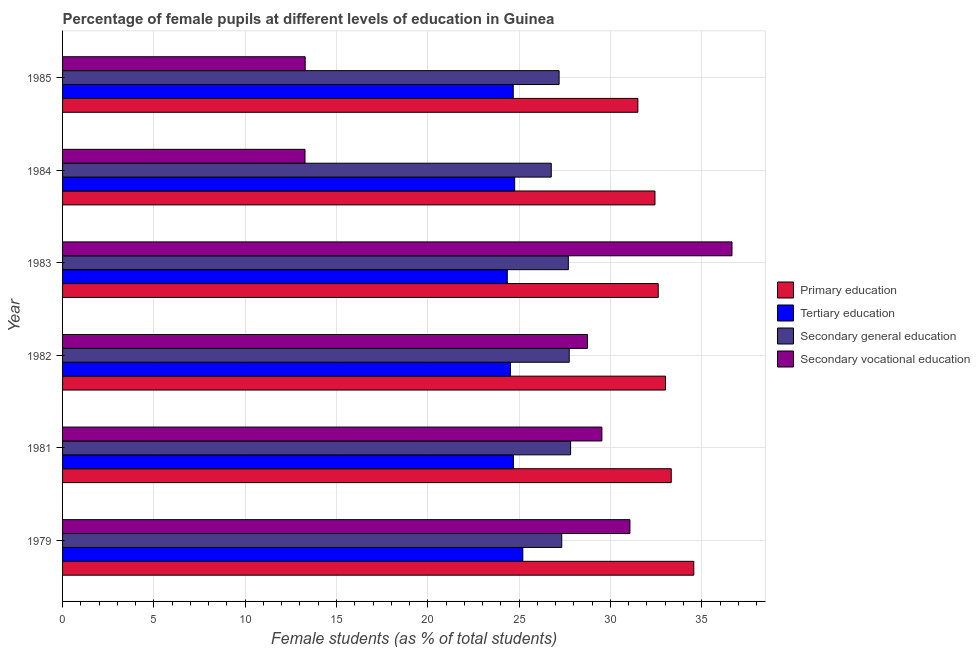How many different coloured bars are there?
Provide a short and direct response. 4. How many groups of bars are there?
Offer a very short reply. 6. How many bars are there on the 3rd tick from the top?
Offer a very short reply. 4. In how many cases, is the number of bars for a given year not equal to the number of legend labels?
Make the answer very short. 0. What is the percentage of female students in tertiary education in 1983?
Keep it short and to the point. 24.35. Across all years, what is the maximum percentage of female students in primary education?
Give a very brief answer. 34.56. Across all years, what is the minimum percentage of female students in secondary vocational education?
Your response must be concise. 13.27. In which year was the percentage of female students in secondary vocational education minimum?
Give a very brief answer. 1984. What is the total percentage of female students in tertiary education in the graph?
Your answer should be very brief. 148.2. What is the difference between the percentage of female students in tertiary education in 1984 and that in 1985?
Provide a short and direct response. 0.08. What is the difference between the percentage of female students in tertiary education in 1982 and the percentage of female students in primary education in 1985?
Offer a very short reply. -6.98. What is the average percentage of female students in tertiary education per year?
Provide a succinct answer. 24.7. In the year 1982, what is the difference between the percentage of female students in primary education and percentage of female students in secondary vocational education?
Give a very brief answer. 4.27. In how many years, is the percentage of female students in secondary vocational education greater than 8 %?
Make the answer very short. 6. What is the ratio of the percentage of female students in primary education in 1984 to that in 1985?
Keep it short and to the point. 1.03. Is the difference between the percentage of female students in secondary education in 1979 and 1984 greater than the difference between the percentage of female students in primary education in 1979 and 1984?
Keep it short and to the point. No. What is the difference between the highest and the second highest percentage of female students in tertiary education?
Your response must be concise. 0.45. What is the difference between the highest and the lowest percentage of female students in secondary education?
Your answer should be compact. 1.06. In how many years, is the percentage of female students in primary education greater than the average percentage of female students in primary education taken over all years?
Offer a very short reply. 3. Is the sum of the percentage of female students in tertiary education in 1983 and 1984 greater than the maximum percentage of female students in secondary vocational education across all years?
Give a very brief answer. Yes. What does the 2nd bar from the top in 1983 represents?
Provide a short and direct response. Secondary general education. What does the 4th bar from the bottom in 1979 represents?
Provide a succinct answer. Secondary vocational education. What is the difference between two consecutive major ticks on the X-axis?
Your answer should be compact. 5. Are the values on the major ticks of X-axis written in scientific E-notation?
Give a very brief answer. No. Does the graph contain any zero values?
Your answer should be compact. No. Does the graph contain grids?
Ensure brevity in your answer.  Yes. Where does the legend appear in the graph?
Provide a short and direct response. Center right. How are the legend labels stacked?
Make the answer very short. Vertical. What is the title of the graph?
Your response must be concise. Percentage of female pupils at different levels of education in Guinea. Does "Luxembourg" appear as one of the legend labels in the graph?
Your answer should be compact. No. What is the label or title of the X-axis?
Keep it short and to the point. Female students (as % of total students). What is the Female students (as % of total students) of Primary education in 1979?
Make the answer very short. 34.56. What is the Female students (as % of total students) of Tertiary education in 1979?
Your response must be concise. 25.2. What is the Female students (as % of total students) of Secondary general education in 1979?
Ensure brevity in your answer.  27.33. What is the Female students (as % of total students) of Secondary vocational education in 1979?
Ensure brevity in your answer.  31.07. What is the Female students (as % of total students) in Primary education in 1981?
Your answer should be very brief. 33.33. What is the Female students (as % of total students) of Tertiary education in 1981?
Offer a terse response. 24.69. What is the Female students (as % of total students) in Secondary general education in 1981?
Give a very brief answer. 27.82. What is the Female students (as % of total students) in Secondary vocational education in 1981?
Offer a very short reply. 29.53. What is the Female students (as % of total students) of Primary education in 1982?
Your answer should be very brief. 33.02. What is the Female students (as % of total students) of Tertiary education in 1982?
Your response must be concise. 24.52. What is the Female students (as % of total students) in Secondary general education in 1982?
Your response must be concise. 27.74. What is the Female students (as % of total students) of Secondary vocational education in 1982?
Give a very brief answer. 28.74. What is the Female students (as % of total students) of Primary education in 1983?
Offer a terse response. 32.62. What is the Female students (as % of total students) in Tertiary education in 1983?
Keep it short and to the point. 24.35. What is the Female students (as % of total students) in Secondary general education in 1983?
Your answer should be very brief. 27.7. What is the Female students (as % of total students) of Secondary vocational education in 1983?
Make the answer very short. 36.66. What is the Female students (as % of total students) of Primary education in 1984?
Your response must be concise. 32.44. What is the Female students (as % of total students) of Tertiary education in 1984?
Make the answer very short. 24.76. What is the Female students (as % of total students) in Secondary general education in 1984?
Your answer should be compact. 26.76. What is the Female students (as % of total students) in Secondary vocational education in 1984?
Make the answer very short. 13.27. What is the Female students (as % of total students) in Primary education in 1985?
Offer a very short reply. 31.5. What is the Female students (as % of total students) in Tertiary education in 1985?
Give a very brief answer. 24.68. What is the Female students (as % of total students) in Secondary general education in 1985?
Provide a short and direct response. 27.19. What is the Female students (as % of total students) of Secondary vocational education in 1985?
Offer a terse response. 13.29. Across all years, what is the maximum Female students (as % of total students) in Primary education?
Keep it short and to the point. 34.56. Across all years, what is the maximum Female students (as % of total students) in Tertiary education?
Your answer should be very brief. 25.2. Across all years, what is the maximum Female students (as % of total students) in Secondary general education?
Your answer should be very brief. 27.82. Across all years, what is the maximum Female students (as % of total students) in Secondary vocational education?
Provide a short and direct response. 36.66. Across all years, what is the minimum Female students (as % of total students) in Primary education?
Keep it short and to the point. 31.5. Across all years, what is the minimum Female students (as % of total students) in Tertiary education?
Provide a succinct answer. 24.35. Across all years, what is the minimum Female students (as % of total students) in Secondary general education?
Offer a terse response. 26.76. Across all years, what is the minimum Female students (as % of total students) in Secondary vocational education?
Offer a terse response. 13.27. What is the total Female students (as % of total students) of Primary education in the graph?
Your response must be concise. 197.47. What is the total Female students (as % of total students) in Tertiary education in the graph?
Give a very brief answer. 148.2. What is the total Female students (as % of total students) of Secondary general education in the graph?
Offer a very short reply. 164.54. What is the total Female students (as % of total students) of Secondary vocational education in the graph?
Offer a very short reply. 152.56. What is the difference between the Female students (as % of total students) of Primary education in 1979 and that in 1981?
Keep it short and to the point. 1.23. What is the difference between the Female students (as % of total students) of Tertiary education in 1979 and that in 1981?
Give a very brief answer. 0.51. What is the difference between the Female students (as % of total students) in Secondary general education in 1979 and that in 1981?
Keep it short and to the point. -0.49. What is the difference between the Female students (as % of total students) of Secondary vocational education in 1979 and that in 1981?
Make the answer very short. 1.54. What is the difference between the Female students (as % of total students) in Primary education in 1979 and that in 1982?
Offer a terse response. 1.55. What is the difference between the Female students (as % of total students) in Tertiary education in 1979 and that in 1982?
Give a very brief answer. 0.68. What is the difference between the Female students (as % of total students) of Secondary general education in 1979 and that in 1982?
Offer a terse response. -0.41. What is the difference between the Female students (as % of total students) in Secondary vocational education in 1979 and that in 1982?
Your answer should be compact. 2.32. What is the difference between the Female students (as % of total students) in Primary education in 1979 and that in 1983?
Give a very brief answer. 1.95. What is the difference between the Female students (as % of total students) in Tertiary education in 1979 and that in 1983?
Provide a succinct answer. 0.85. What is the difference between the Female students (as % of total students) of Secondary general education in 1979 and that in 1983?
Make the answer very short. -0.36. What is the difference between the Female students (as % of total students) in Secondary vocational education in 1979 and that in 1983?
Provide a short and direct response. -5.59. What is the difference between the Female students (as % of total students) of Primary education in 1979 and that in 1984?
Your answer should be compact. 2.13. What is the difference between the Female students (as % of total students) in Tertiary education in 1979 and that in 1984?
Offer a terse response. 0.45. What is the difference between the Female students (as % of total students) of Secondary general education in 1979 and that in 1984?
Provide a short and direct response. 0.57. What is the difference between the Female students (as % of total students) of Secondary vocational education in 1979 and that in 1984?
Your response must be concise. 17.79. What is the difference between the Female students (as % of total students) of Primary education in 1979 and that in 1985?
Your answer should be compact. 3.06. What is the difference between the Female students (as % of total students) of Tertiary education in 1979 and that in 1985?
Your response must be concise. 0.52. What is the difference between the Female students (as % of total students) of Secondary general education in 1979 and that in 1985?
Ensure brevity in your answer.  0.14. What is the difference between the Female students (as % of total students) in Secondary vocational education in 1979 and that in 1985?
Your answer should be very brief. 17.78. What is the difference between the Female students (as % of total students) in Primary education in 1981 and that in 1982?
Give a very brief answer. 0.32. What is the difference between the Female students (as % of total students) of Tertiary education in 1981 and that in 1982?
Your answer should be compact. 0.16. What is the difference between the Female students (as % of total students) in Secondary general education in 1981 and that in 1982?
Your answer should be very brief. 0.07. What is the difference between the Female students (as % of total students) of Secondary vocational education in 1981 and that in 1982?
Your response must be concise. 0.79. What is the difference between the Female students (as % of total students) of Primary education in 1981 and that in 1983?
Provide a short and direct response. 0.71. What is the difference between the Female students (as % of total students) in Tertiary education in 1981 and that in 1983?
Offer a very short reply. 0.34. What is the difference between the Female students (as % of total students) of Secondary general education in 1981 and that in 1983?
Give a very brief answer. 0.12. What is the difference between the Female students (as % of total students) in Secondary vocational education in 1981 and that in 1983?
Your answer should be very brief. -7.12. What is the difference between the Female students (as % of total students) of Primary education in 1981 and that in 1984?
Make the answer very short. 0.89. What is the difference between the Female students (as % of total students) in Tertiary education in 1981 and that in 1984?
Make the answer very short. -0.07. What is the difference between the Female students (as % of total students) of Secondary general education in 1981 and that in 1984?
Your answer should be very brief. 1.06. What is the difference between the Female students (as % of total students) of Secondary vocational education in 1981 and that in 1984?
Provide a short and direct response. 16.26. What is the difference between the Female students (as % of total students) of Primary education in 1981 and that in 1985?
Your answer should be compact. 1.83. What is the difference between the Female students (as % of total students) in Tertiary education in 1981 and that in 1985?
Provide a short and direct response. 0.01. What is the difference between the Female students (as % of total students) of Secondary general education in 1981 and that in 1985?
Keep it short and to the point. 0.63. What is the difference between the Female students (as % of total students) in Secondary vocational education in 1981 and that in 1985?
Offer a very short reply. 16.25. What is the difference between the Female students (as % of total students) in Primary education in 1982 and that in 1983?
Your answer should be very brief. 0.4. What is the difference between the Female students (as % of total students) in Tertiary education in 1982 and that in 1983?
Offer a terse response. 0.17. What is the difference between the Female students (as % of total students) in Secondary general education in 1982 and that in 1983?
Provide a short and direct response. 0.05. What is the difference between the Female students (as % of total students) in Secondary vocational education in 1982 and that in 1983?
Ensure brevity in your answer.  -7.91. What is the difference between the Female students (as % of total students) of Primary education in 1982 and that in 1984?
Provide a short and direct response. 0.58. What is the difference between the Female students (as % of total students) in Tertiary education in 1982 and that in 1984?
Offer a terse response. -0.23. What is the difference between the Female students (as % of total students) of Secondary general education in 1982 and that in 1984?
Your answer should be compact. 0.98. What is the difference between the Female students (as % of total students) of Secondary vocational education in 1982 and that in 1984?
Offer a terse response. 15.47. What is the difference between the Female students (as % of total students) of Primary education in 1982 and that in 1985?
Your answer should be very brief. 1.51. What is the difference between the Female students (as % of total students) of Tertiary education in 1982 and that in 1985?
Keep it short and to the point. -0.15. What is the difference between the Female students (as % of total students) of Secondary general education in 1982 and that in 1985?
Keep it short and to the point. 0.55. What is the difference between the Female students (as % of total students) in Secondary vocational education in 1982 and that in 1985?
Offer a terse response. 15.46. What is the difference between the Female students (as % of total students) of Primary education in 1983 and that in 1984?
Offer a terse response. 0.18. What is the difference between the Female students (as % of total students) of Tertiary education in 1983 and that in 1984?
Give a very brief answer. -0.4. What is the difference between the Female students (as % of total students) in Secondary general education in 1983 and that in 1984?
Provide a succinct answer. 0.94. What is the difference between the Female students (as % of total students) of Secondary vocational education in 1983 and that in 1984?
Provide a short and direct response. 23.38. What is the difference between the Female students (as % of total students) in Primary education in 1983 and that in 1985?
Your answer should be compact. 1.11. What is the difference between the Female students (as % of total students) of Tertiary education in 1983 and that in 1985?
Ensure brevity in your answer.  -0.33. What is the difference between the Female students (as % of total students) of Secondary general education in 1983 and that in 1985?
Provide a succinct answer. 0.51. What is the difference between the Female students (as % of total students) in Secondary vocational education in 1983 and that in 1985?
Keep it short and to the point. 23.37. What is the difference between the Female students (as % of total students) in Primary education in 1984 and that in 1985?
Ensure brevity in your answer.  0.94. What is the difference between the Female students (as % of total students) in Tertiary education in 1984 and that in 1985?
Make the answer very short. 0.08. What is the difference between the Female students (as % of total students) in Secondary general education in 1984 and that in 1985?
Offer a very short reply. -0.43. What is the difference between the Female students (as % of total students) of Secondary vocational education in 1984 and that in 1985?
Your answer should be very brief. -0.01. What is the difference between the Female students (as % of total students) in Primary education in 1979 and the Female students (as % of total students) in Tertiary education in 1981?
Offer a terse response. 9.88. What is the difference between the Female students (as % of total students) in Primary education in 1979 and the Female students (as % of total students) in Secondary general education in 1981?
Provide a short and direct response. 6.75. What is the difference between the Female students (as % of total students) in Primary education in 1979 and the Female students (as % of total students) in Secondary vocational education in 1981?
Your response must be concise. 5.03. What is the difference between the Female students (as % of total students) of Tertiary education in 1979 and the Female students (as % of total students) of Secondary general education in 1981?
Ensure brevity in your answer.  -2.62. What is the difference between the Female students (as % of total students) of Tertiary education in 1979 and the Female students (as % of total students) of Secondary vocational education in 1981?
Make the answer very short. -4.33. What is the difference between the Female students (as % of total students) in Secondary general education in 1979 and the Female students (as % of total students) in Secondary vocational education in 1981?
Your answer should be compact. -2.2. What is the difference between the Female students (as % of total students) of Primary education in 1979 and the Female students (as % of total students) of Tertiary education in 1982?
Ensure brevity in your answer.  10.04. What is the difference between the Female students (as % of total students) of Primary education in 1979 and the Female students (as % of total students) of Secondary general education in 1982?
Ensure brevity in your answer.  6.82. What is the difference between the Female students (as % of total students) of Primary education in 1979 and the Female students (as % of total students) of Secondary vocational education in 1982?
Make the answer very short. 5.82. What is the difference between the Female students (as % of total students) of Tertiary education in 1979 and the Female students (as % of total students) of Secondary general education in 1982?
Keep it short and to the point. -2.54. What is the difference between the Female students (as % of total students) in Tertiary education in 1979 and the Female students (as % of total students) in Secondary vocational education in 1982?
Make the answer very short. -3.54. What is the difference between the Female students (as % of total students) in Secondary general education in 1979 and the Female students (as % of total students) in Secondary vocational education in 1982?
Provide a short and direct response. -1.41. What is the difference between the Female students (as % of total students) in Primary education in 1979 and the Female students (as % of total students) in Tertiary education in 1983?
Your answer should be very brief. 10.21. What is the difference between the Female students (as % of total students) in Primary education in 1979 and the Female students (as % of total students) in Secondary general education in 1983?
Ensure brevity in your answer.  6.87. What is the difference between the Female students (as % of total students) of Primary education in 1979 and the Female students (as % of total students) of Secondary vocational education in 1983?
Your answer should be very brief. -2.09. What is the difference between the Female students (as % of total students) of Tertiary education in 1979 and the Female students (as % of total students) of Secondary general education in 1983?
Your answer should be very brief. -2.49. What is the difference between the Female students (as % of total students) in Tertiary education in 1979 and the Female students (as % of total students) in Secondary vocational education in 1983?
Offer a terse response. -11.45. What is the difference between the Female students (as % of total students) of Secondary general education in 1979 and the Female students (as % of total students) of Secondary vocational education in 1983?
Offer a very short reply. -9.32. What is the difference between the Female students (as % of total students) of Primary education in 1979 and the Female students (as % of total students) of Tertiary education in 1984?
Your response must be concise. 9.81. What is the difference between the Female students (as % of total students) of Primary education in 1979 and the Female students (as % of total students) of Secondary general education in 1984?
Offer a very short reply. 7.8. What is the difference between the Female students (as % of total students) in Primary education in 1979 and the Female students (as % of total students) in Secondary vocational education in 1984?
Your answer should be compact. 21.29. What is the difference between the Female students (as % of total students) of Tertiary education in 1979 and the Female students (as % of total students) of Secondary general education in 1984?
Provide a succinct answer. -1.56. What is the difference between the Female students (as % of total students) of Tertiary education in 1979 and the Female students (as % of total students) of Secondary vocational education in 1984?
Offer a very short reply. 11.93. What is the difference between the Female students (as % of total students) in Secondary general education in 1979 and the Female students (as % of total students) in Secondary vocational education in 1984?
Offer a terse response. 14.06. What is the difference between the Female students (as % of total students) in Primary education in 1979 and the Female students (as % of total students) in Tertiary education in 1985?
Offer a very short reply. 9.89. What is the difference between the Female students (as % of total students) in Primary education in 1979 and the Female students (as % of total students) in Secondary general education in 1985?
Provide a succinct answer. 7.38. What is the difference between the Female students (as % of total students) in Primary education in 1979 and the Female students (as % of total students) in Secondary vocational education in 1985?
Your response must be concise. 21.28. What is the difference between the Female students (as % of total students) in Tertiary education in 1979 and the Female students (as % of total students) in Secondary general education in 1985?
Provide a succinct answer. -1.99. What is the difference between the Female students (as % of total students) of Tertiary education in 1979 and the Female students (as % of total students) of Secondary vocational education in 1985?
Give a very brief answer. 11.92. What is the difference between the Female students (as % of total students) in Secondary general education in 1979 and the Female students (as % of total students) in Secondary vocational education in 1985?
Your answer should be compact. 14.05. What is the difference between the Female students (as % of total students) in Primary education in 1981 and the Female students (as % of total students) in Tertiary education in 1982?
Your answer should be compact. 8.81. What is the difference between the Female students (as % of total students) in Primary education in 1981 and the Female students (as % of total students) in Secondary general education in 1982?
Offer a very short reply. 5.59. What is the difference between the Female students (as % of total students) of Primary education in 1981 and the Female students (as % of total students) of Secondary vocational education in 1982?
Make the answer very short. 4.59. What is the difference between the Female students (as % of total students) in Tertiary education in 1981 and the Female students (as % of total students) in Secondary general education in 1982?
Your answer should be compact. -3.06. What is the difference between the Female students (as % of total students) in Tertiary education in 1981 and the Female students (as % of total students) in Secondary vocational education in 1982?
Keep it short and to the point. -4.06. What is the difference between the Female students (as % of total students) in Secondary general education in 1981 and the Female students (as % of total students) in Secondary vocational education in 1982?
Provide a succinct answer. -0.93. What is the difference between the Female students (as % of total students) in Primary education in 1981 and the Female students (as % of total students) in Tertiary education in 1983?
Your answer should be compact. 8.98. What is the difference between the Female students (as % of total students) of Primary education in 1981 and the Female students (as % of total students) of Secondary general education in 1983?
Ensure brevity in your answer.  5.64. What is the difference between the Female students (as % of total students) in Primary education in 1981 and the Female students (as % of total students) in Secondary vocational education in 1983?
Make the answer very short. -3.33. What is the difference between the Female students (as % of total students) in Tertiary education in 1981 and the Female students (as % of total students) in Secondary general education in 1983?
Offer a terse response. -3.01. What is the difference between the Female students (as % of total students) of Tertiary education in 1981 and the Female students (as % of total students) of Secondary vocational education in 1983?
Your answer should be very brief. -11.97. What is the difference between the Female students (as % of total students) in Secondary general education in 1981 and the Female students (as % of total students) in Secondary vocational education in 1983?
Give a very brief answer. -8.84. What is the difference between the Female students (as % of total students) of Primary education in 1981 and the Female students (as % of total students) of Tertiary education in 1984?
Provide a short and direct response. 8.57. What is the difference between the Female students (as % of total students) of Primary education in 1981 and the Female students (as % of total students) of Secondary general education in 1984?
Offer a terse response. 6.57. What is the difference between the Female students (as % of total students) of Primary education in 1981 and the Female students (as % of total students) of Secondary vocational education in 1984?
Give a very brief answer. 20.06. What is the difference between the Female students (as % of total students) of Tertiary education in 1981 and the Female students (as % of total students) of Secondary general education in 1984?
Your response must be concise. -2.07. What is the difference between the Female students (as % of total students) in Tertiary education in 1981 and the Female students (as % of total students) in Secondary vocational education in 1984?
Your response must be concise. 11.41. What is the difference between the Female students (as % of total students) of Secondary general education in 1981 and the Female students (as % of total students) of Secondary vocational education in 1984?
Ensure brevity in your answer.  14.54. What is the difference between the Female students (as % of total students) in Primary education in 1981 and the Female students (as % of total students) in Tertiary education in 1985?
Offer a terse response. 8.65. What is the difference between the Female students (as % of total students) in Primary education in 1981 and the Female students (as % of total students) in Secondary general education in 1985?
Give a very brief answer. 6.14. What is the difference between the Female students (as % of total students) of Primary education in 1981 and the Female students (as % of total students) of Secondary vocational education in 1985?
Your answer should be very brief. 20.04. What is the difference between the Female students (as % of total students) of Tertiary education in 1981 and the Female students (as % of total students) of Secondary general education in 1985?
Keep it short and to the point. -2.5. What is the difference between the Female students (as % of total students) of Tertiary education in 1981 and the Female students (as % of total students) of Secondary vocational education in 1985?
Offer a very short reply. 11.4. What is the difference between the Female students (as % of total students) in Secondary general education in 1981 and the Female students (as % of total students) in Secondary vocational education in 1985?
Your response must be concise. 14.53. What is the difference between the Female students (as % of total students) in Primary education in 1982 and the Female students (as % of total students) in Tertiary education in 1983?
Your answer should be very brief. 8.66. What is the difference between the Female students (as % of total students) of Primary education in 1982 and the Female students (as % of total students) of Secondary general education in 1983?
Your answer should be compact. 5.32. What is the difference between the Female students (as % of total students) in Primary education in 1982 and the Female students (as % of total students) in Secondary vocational education in 1983?
Offer a very short reply. -3.64. What is the difference between the Female students (as % of total students) of Tertiary education in 1982 and the Female students (as % of total students) of Secondary general education in 1983?
Keep it short and to the point. -3.17. What is the difference between the Female students (as % of total students) in Tertiary education in 1982 and the Female students (as % of total students) in Secondary vocational education in 1983?
Ensure brevity in your answer.  -12.13. What is the difference between the Female students (as % of total students) of Secondary general education in 1982 and the Female students (as % of total students) of Secondary vocational education in 1983?
Keep it short and to the point. -8.91. What is the difference between the Female students (as % of total students) in Primary education in 1982 and the Female students (as % of total students) in Tertiary education in 1984?
Offer a very short reply. 8.26. What is the difference between the Female students (as % of total students) of Primary education in 1982 and the Female students (as % of total students) of Secondary general education in 1984?
Offer a very short reply. 6.26. What is the difference between the Female students (as % of total students) in Primary education in 1982 and the Female students (as % of total students) in Secondary vocational education in 1984?
Provide a succinct answer. 19.74. What is the difference between the Female students (as % of total students) in Tertiary education in 1982 and the Female students (as % of total students) in Secondary general education in 1984?
Your response must be concise. -2.24. What is the difference between the Female students (as % of total students) of Tertiary education in 1982 and the Female students (as % of total students) of Secondary vocational education in 1984?
Provide a succinct answer. 11.25. What is the difference between the Female students (as % of total students) of Secondary general education in 1982 and the Female students (as % of total students) of Secondary vocational education in 1984?
Offer a very short reply. 14.47. What is the difference between the Female students (as % of total students) of Primary education in 1982 and the Female students (as % of total students) of Tertiary education in 1985?
Your response must be concise. 8.34. What is the difference between the Female students (as % of total students) of Primary education in 1982 and the Female students (as % of total students) of Secondary general education in 1985?
Give a very brief answer. 5.83. What is the difference between the Female students (as % of total students) of Primary education in 1982 and the Female students (as % of total students) of Secondary vocational education in 1985?
Make the answer very short. 19.73. What is the difference between the Female students (as % of total students) in Tertiary education in 1982 and the Female students (as % of total students) in Secondary general education in 1985?
Provide a short and direct response. -2.66. What is the difference between the Female students (as % of total students) in Tertiary education in 1982 and the Female students (as % of total students) in Secondary vocational education in 1985?
Keep it short and to the point. 11.24. What is the difference between the Female students (as % of total students) in Secondary general education in 1982 and the Female students (as % of total students) in Secondary vocational education in 1985?
Your answer should be compact. 14.46. What is the difference between the Female students (as % of total students) in Primary education in 1983 and the Female students (as % of total students) in Tertiary education in 1984?
Provide a short and direct response. 7.86. What is the difference between the Female students (as % of total students) of Primary education in 1983 and the Female students (as % of total students) of Secondary general education in 1984?
Make the answer very short. 5.86. What is the difference between the Female students (as % of total students) in Primary education in 1983 and the Female students (as % of total students) in Secondary vocational education in 1984?
Offer a terse response. 19.34. What is the difference between the Female students (as % of total students) in Tertiary education in 1983 and the Female students (as % of total students) in Secondary general education in 1984?
Offer a terse response. -2.41. What is the difference between the Female students (as % of total students) in Tertiary education in 1983 and the Female students (as % of total students) in Secondary vocational education in 1984?
Give a very brief answer. 11.08. What is the difference between the Female students (as % of total students) of Secondary general education in 1983 and the Female students (as % of total students) of Secondary vocational education in 1984?
Offer a terse response. 14.42. What is the difference between the Female students (as % of total students) in Primary education in 1983 and the Female students (as % of total students) in Tertiary education in 1985?
Your answer should be very brief. 7.94. What is the difference between the Female students (as % of total students) in Primary education in 1983 and the Female students (as % of total students) in Secondary general education in 1985?
Your answer should be compact. 5.43. What is the difference between the Female students (as % of total students) in Primary education in 1983 and the Female students (as % of total students) in Secondary vocational education in 1985?
Your answer should be very brief. 19.33. What is the difference between the Female students (as % of total students) of Tertiary education in 1983 and the Female students (as % of total students) of Secondary general education in 1985?
Your answer should be compact. -2.84. What is the difference between the Female students (as % of total students) in Tertiary education in 1983 and the Female students (as % of total students) in Secondary vocational education in 1985?
Your response must be concise. 11.07. What is the difference between the Female students (as % of total students) in Secondary general education in 1983 and the Female students (as % of total students) in Secondary vocational education in 1985?
Your response must be concise. 14.41. What is the difference between the Female students (as % of total students) in Primary education in 1984 and the Female students (as % of total students) in Tertiary education in 1985?
Offer a terse response. 7.76. What is the difference between the Female students (as % of total students) in Primary education in 1984 and the Female students (as % of total students) in Secondary general education in 1985?
Ensure brevity in your answer.  5.25. What is the difference between the Female students (as % of total students) of Primary education in 1984 and the Female students (as % of total students) of Secondary vocational education in 1985?
Make the answer very short. 19.15. What is the difference between the Female students (as % of total students) of Tertiary education in 1984 and the Female students (as % of total students) of Secondary general education in 1985?
Your answer should be compact. -2.43. What is the difference between the Female students (as % of total students) in Tertiary education in 1984 and the Female students (as % of total students) in Secondary vocational education in 1985?
Keep it short and to the point. 11.47. What is the difference between the Female students (as % of total students) of Secondary general education in 1984 and the Female students (as % of total students) of Secondary vocational education in 1985?
Keep it short and to the point. 13.47. What is the average Female students (as % of total students) in Primary education per year?
Ensure brevity in your answer.  32.91. What is the average Female students (as % of total students) of Tertiary education per year?
Give a very brief answer. 24.7. What is the average Female students (as % of total students) in Secondary general education per year?
Make the answer very short. 27.42. What is the average Female students (as % of total students) in Secondary vocational education per year?
Provide a short and direct response. 25.43. In the year 1979, what is the difference between the Female students (as % of total students) of Primary education and Female students (as % of total students) of Tertiary education?
Offer a very short reply. 9.36. In the year 1979, what is the difference between the Female students (as % of total students) in Primary education and Female students (as % of total students) in Secondary general education?
Offer a very short reply. 7.23. In the year 1979, what is the difference between the Female students (as % of total students) in Primary education and Female students (as % of total students) in Secondary vocational education?
Give a very brief answer. 3.5. In the year 1979, what is the difference between the Female students (as % of total students) in Tertiary education and Female students (as % of total students) in Secondary general education?
Your answer should be compact. -2.13. In the year 1979, what is the difference between the Female students (as % of total students) in Tertiary education and Female students (as % of total students) in Secondary vocational education?
Offer a terse response. -5.87. In the year 1979, what is the difference between the Female students (as % of total students) of Secondary general education and Female students (as % of total students) of Secondary vocational education?
Ensure brevity in your answer.  -3.73. In the year 1981, what is the difference between the Female students (as % of total students) of Primary education and Female students (as % of total students) of Tertiary education?
Provide a succinct answer. 8.64. In the year 1981, what is the difference between the Female students (as % of total students) of Primary education and Female students (as % of total students) of Secondary general education?
Ensure brevity in your answer.  5.51. In the year 1981, what is the difference between the Female students (as % of total students) in Primary education and Female students (as % of total students) in Secondary vocational education?
Provide a succinct answer. 3.8. In the year 1981, what is the difference between the Female students (as % of total students) in Tertiary education and Female students (as % of total students) in Secondary general education?
Your answer should be very brief. -3.13. In the year 1981, what is the difference between the Female students (as % of total students) of Tertiary education and Female students (as % of total students) of Secondary vocational education?
Your answer should be very brief. -4.84. In the year 1981, what is the difference between the Female students (as % of total students) of Secondary general education and Female students (as % of total students) of Secondary vocational education?
Provide a succinct answer. -1.71. In the year 1982, what is the difference between the Female students (as % of total students) of Primary education and Female students (as % of total students) of Tertiary education?
Give a very brief answer. 8.49. In the year 1982, what is the difference between the Female students (as % of total students) in Primary education and Female students (as % of total students) in Secondary general education?
Offer a very short reply. 5.27. In the year 1982, what is the difference between the Female students (as % of total students) in Primary education and Female students (as % of total students) in Secondary vocational education?
Your response must be concise. 4.27. In the year 1982, what is the difference between the Female students (as % of total students) in Tertiary education and Female students (as % of total students) in Secondary general education?
Give a very brief answer. -3.22. In the year 1982, what is the difference between the Female students (as % of total students) of Tertiary education and Female students (as % of total students) of Secondary vocational education?
Provide a succinct answer. -4.22. In the year 1982, what is the difference between the Female students (as % of total students) of Secondary general education and Female students (as % of total students) of Secondary vocational education?
Offer a very short reply. -1. In the year 1983, what is the difference between the Female students (as % of total students) in Primary education and Female students (as % of total students) in Tertiary education?
Your answer should be very brief. 8.26. In the year 1983, what is the difference between the Female students (as % of total students) in Primary education and Female students (as % of total students) in Secondary general education?
Your response must be concise. 4.92. In the year 1983, what is the difference between the Female students (as % of total students) of Primary education and Female students (as % of total students) of Secondary vocational education?
Your response must be concise. -4.04. In the year 1983, what is the difference between the Female students (as % of total students) of Tertiary education and Female students (as % of total students) of Secondary general education?
Provide a short and direct response. -3.34. In the year 1983, what is the difference between the Female students (as % of total students) of Tertiary education and Female students (as % of total students) of Secondary vocational education?
Make the answer very short. -12.3. In the year 1983, what is the difference between the Female students (as % of total students) of Secondary general education and Female students (as % of total students) of Secondary vocational education?
Give a very brief answer. -8.96. In the year 1984, what is the difference between the Female students (as % of total students) in Primary education and Female students (as % of total students) in Tertiary education?
Make the answer very short. 7.68. In the year 1984, what is the difference between the Female students (as % of total students) in Primary education and Female students (as % of total students) in Secondary general education?
Give a very brief answer. 5.68. In the year 1984, what is the difference between the Female students (as % of total students) of Primary education and Female students (as % of total students) of Secondary vocational education?
Your answer should be very brief. 19.16. In the year 1984, what is the difference between the Female students (as % of total students) in Tertiary education and Female students (as % of total students) in Secondary general education?
Provide a succinct answer. -2. In the year 1984, what is the difference between the Female students (as % of total students) of Tertiary education and Female students (as % of total students) of Secondary vocational education?
Your answer should be compact. 11.48. In the year 1984, what is the difference between the Female students (as % of total students) in Secondary general education and Female students (as % of total students) in Secondary vocational education?
Make the answer very short. 13.49. In the year 1985, what is the difference between the Female students (as % of total students) in Primary education and Female students (as % of total students) in Tertiary education?
Give a very brief answer. 6.82. In the year 1985, what is the difference between the Female students (as % of total students) of Primary education and Female students (as % of total students) of Secondary general education?
Your answer should be compact. 4.31. In the year 1985, what is the difference between the Female students (as % of total students) of Primary education and Female students (as % of total students) of Secondary vocational education?
Give a very brief answer. 18.22. In the year 1985, what is the difference between the Female students (as % of total students) of Tertiary education and Female students (as % of total students) of Secondary general education?
Keep it short and to the point. -2.51. In the year 1985, what is the difference between the Female students (as % of total students) in Tertiary education and Female students (as % of total students) in Secondary vocational education?
Your response must be concise. 11.39. In the year 1985, what is the difference between the Female students (as % of total students) of Secondary general education and Female students (as % of total students) of Secondary vocational education?
Offer a terse response. 13.9. What is the ratio of the Female students (as % of total students) of Tertiary education in 1979 to that in 1981?
Provide a succinct answer. 1.02. What is the ratio of the Female students (as % of total students) in Secondary general education in 1979 to that in 1981?
Your answer should be very brief. 0.98. What is the ratio of the Female students (as % of total students) in Secondary vocational education in 1979 to that in 1981?
Offer a terse response. 1.05. What is the ratio of the Female students (as % of total students) in Primary education in 1979 to that in 1982?
Make the answer very short. 1.05. What is the ratio of the Female students (as % of total students) of Tertiary education in 1979 to that in 1982?
Ensure brevity in your answer.  1.03. What is the ratio of the Female students (as % of total students) in Secondary general education in 1979 to that in 1982?
Give a very brief answer. 0.99. What is the ratio of the Female students (as % of total students) in Secondary vocational education in 1979 to that in 1982?
Ensure brevity in your answer.  1.08. What is the ratio of the Female students (as % of total students) in Primary education in 1979 to that in 1983?
Your response must be concise. 1.06. What is the ratio of the Female students (as % of total students) in Tertiary education in 1979 to that in 1983?
Provide a succinct answer. 1.03. What is the ratio of the Female students (as % of total students) in Secondary general education in 1979 to that in 1983?
Your answer should be compact. 0.99. What is the ratio of the Female students (as % of total students) of Secondary vocational education in 1979 to that in 1983?
Provide a short and direct response. 0.85. What is the ratio of the Female students (as % of total students) in Primary education in 1979 to that in 1984?
Provide a succinct answer. 1.07. What is the ratio of the Female students (as % of total students) of Tertiary education in 1979 to that in 1984?
Your response must be concise. 1.02. What is the ratio of the Female students (as % of total students) in Secondary general education in 1979 to that in 1984?
Offer a very short reply. 1.02. What is the ratio of the Female students (as % of total students) in Secondary vocational education in 1979 to that in 1984?
Your answer should be very brief. 2.34. What is the ratio of the Female students (as % of total students) of Primary education in 1979 to that in 1985?
Provide a succinct answer. 1.1. What is the ratio of the Female students (as % of total students) of Tertiary education in 1979 to that in 1985?
Offer a very short reply. 1.02. What is the ratio of the Female students (as % of total students) in Secondary general education in 1979 to that in 1985?
Offer a terse response. 1.01. What is the ratio of the Female students (as % of total students) of Secondary vocational education in 1979 to that in 1985?
Give a very brief answer. 2.34. What is the ratio of the Female students (as % of total students) in Primary education in 1981 to that in 1982?
Provide a succinct answer. 1.01. What is the ratio of the Female students (as % of total students) in Tertiary education in 1981 to that in 1982?
Your answer should be compact. 1.01. What is the ratio of the Female students (as % of total students) of Secondary vocational education in 1981 to that in 1982?
Keep it short and to the point. 1.03. What is the ratio of the Female students (as % of total students) of Primary education in 1981 to that in 1983?
Your answer should be compact. 1.02. What is the ratio of the Female students (as % of total students) of Tertiary education in 1981 to that in 1983?
Ensure brevity in your answer.  1.01. What is the ratio of the Female students (as % of total students) in Secondary vocational education in 1981 to that in 1983?
Offer a terse response. 0.81. What is the ratio of the Female students (as % of total students) of Primary education in 1981 to that in 1984?
Make the answer very short. 1.03. What is the ratio of the Female students (as % of total students) in Tertiary education in 1981 to that in 1984?
Offer a terse response. 1. What is the ratio of the Female students (as % of total students) in Secondary general education in 1981 to that in 1984?
Your answer should be compact. 1.04. What is the ratio of the Female students (as % of total students) in Secondary vocational education in 1981 to that in 1984?
Make the answer very short. 2.22. What is the ratio of the Female students (as % of total students) of Primary education in 1981 to that in 1985?
Offer a terse response. 1.06. What is the ratio of the Female students (as % of total students) in Tertiary education in 1981 to that in 1985?
Keep it short and to the point. 1. What is the ratio of the Female students (as % of total students) of Secondary general education in 1981 to that in 1985?
Ensure brevity in your answer.  1.02. What is the ratio of the Female students (as % of total students) in Secondary vocational education in 1981 to that in 1985?
Provide a short and direct response. 2.22. What is the ratio of the Female students (as % of total students) of Primary education in 1982 to that in 1983?
Your answer should be very brief. 1.01. What is the ratio of the Female students (as % of total students) of Tertiary education in 1982 to that in 1983?
Offer a very short reply. 1.01. What is the ratio of the Female students (as % of total students) in Secondary general education in 1982 to that in 1983?
Your answer should be compact. 1. What is the ratio of the Female students (as % of total students) in Secondary vocational education in 1982 to that in 1983?
Ensure brevity in your answer.  0.78. What is the ratio of the Female students (as % of total students) of Primary education in 1982 to that in 1984?
Provide a succinct answer. 1.02. What is the ratio of the Female students (as % of total students) in Tertiary education in 1982 to that in 1984?
Keep it short and to the point. 0.99. What is the ratio of the Female students (as % of total students) in Secondary general education in 1982 to that in 1984?
Make the answer very short. 1.04. What is the ratio of the Female students (as % of total students) of Secondary vocational education in 1982 to that in 1984?
Make the answer very short. 2.17. What is the ratio of the Female students (as % of total students) in Primary education in 1982 to that in 1985?
Make the answer very short. 1.05. What is the ratio of the Female students (as % of total students) of Secondary general education in 1982 to that in 1985?
Make the answer very short. 1.02. What is the ratio of the Female students (as % of total students) of Secondary vocational education in 1982 to that in 1985?
Give a very brief answer. 2.16. What is the ratio of the Female students (as % of total students) in Primary education in 1983 to that in 1984?
Provide a short and direct response. 1.01. What is the ratio of the Female students (as % of total students) of Tertiary education in 1983 to that in 1984?
Your response must be concise. 0.98. What is the ratio of the Female students (as % of total students) in Secondary general education in 1983 to that in 1984?
Give a very brief answer. 1.03. What is the ratio of the Female students (as % of total students) in Secondary vocational education in 1983 to that in 1984?
Offer a very short reply. 2.76. What is the ratio of the Female students (as % of total students) of Primary education in 1983 to that in 1985?
Offer a very short reply. 1.04. What is the ratio of the Female students (as % of total students) in Tertiary education in 1983 to that in 1985?
Provide a succinct answer. 0.99. What is the ratio of the Female students (as % of total students) in Secondary general education in 1983 to that in 1985?
Your answer should be very brief. 1.02. What is the ratio of the Female students (as % of total students) in Secondary vocational education in 1983 to that in 1985?
Offer a terse response. 2.76. What is the ratio of the Female students (as % of total students) of Primary education in 1984 to that in 1985?
Provide a succinct answer. 1.03. What is the ratio of the Female students (as % of total students) of Tertiary education in 1984 to that in 1985?
Make the answer very short. 1. What is the ratio of the Female students (as % of total students) in Secondary general education in 1984 to that in 1985?
Your answer should be very brief. 0.98. What is the ratio of the Female students (as % of total students) of Secondary vocational education in 1984 to that in 1985?
Offer a terse response. 1. What is the difference between the highest and the second highest Female students (as % of total students) of Primary education?
Ensure brevity in your answer.  1.23. What is the difference between the highest and the second highest Female students (as % of total students) in Tertiary education?
Ensure brevity in your answer.  0.45. What is the difference between the highest and the second highest Female students (as % of total students) in Secondary general education?
Ensure brevity in your answer.  0.07. What is the difference between the highest and the second highest Female students (as % of total students) of Secondary vocational education?
Your answer should be compact. 5.59. What is the difference between the highest and the lowest Female students (as % of total students) of Primary education?
Your answer should be very brief. 3.06. What is the difference between the highest and the lowest Female students (as % of total students) in Tertiary education?
Provide a short and direct response. 0.85. What is the difference between the highest and the lowest Female students (as % of total students) of Secondary general education?
Offer a terse response. 1.06. What is the difference between the highest and the lowest Female students (as % of total students) in Secondary vocational education?
Give a very brief answer. 23.38. 